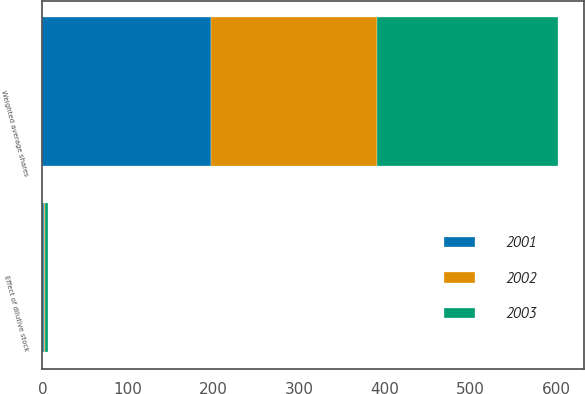<chart> <loc_0><loc_0><loc_500><loc_500><stacked_bar_chart><ecel><fcel>Weighted average shares<fcel>Effect of dilutive stock<nl><fcel>2003<fcel>211.2<fcel>3.5<nl><fcel>2001<fcel>196.8<fcel>2.3<nl><fcel>2002<fcel>194.3<fcel>0.6<nl></chart> 